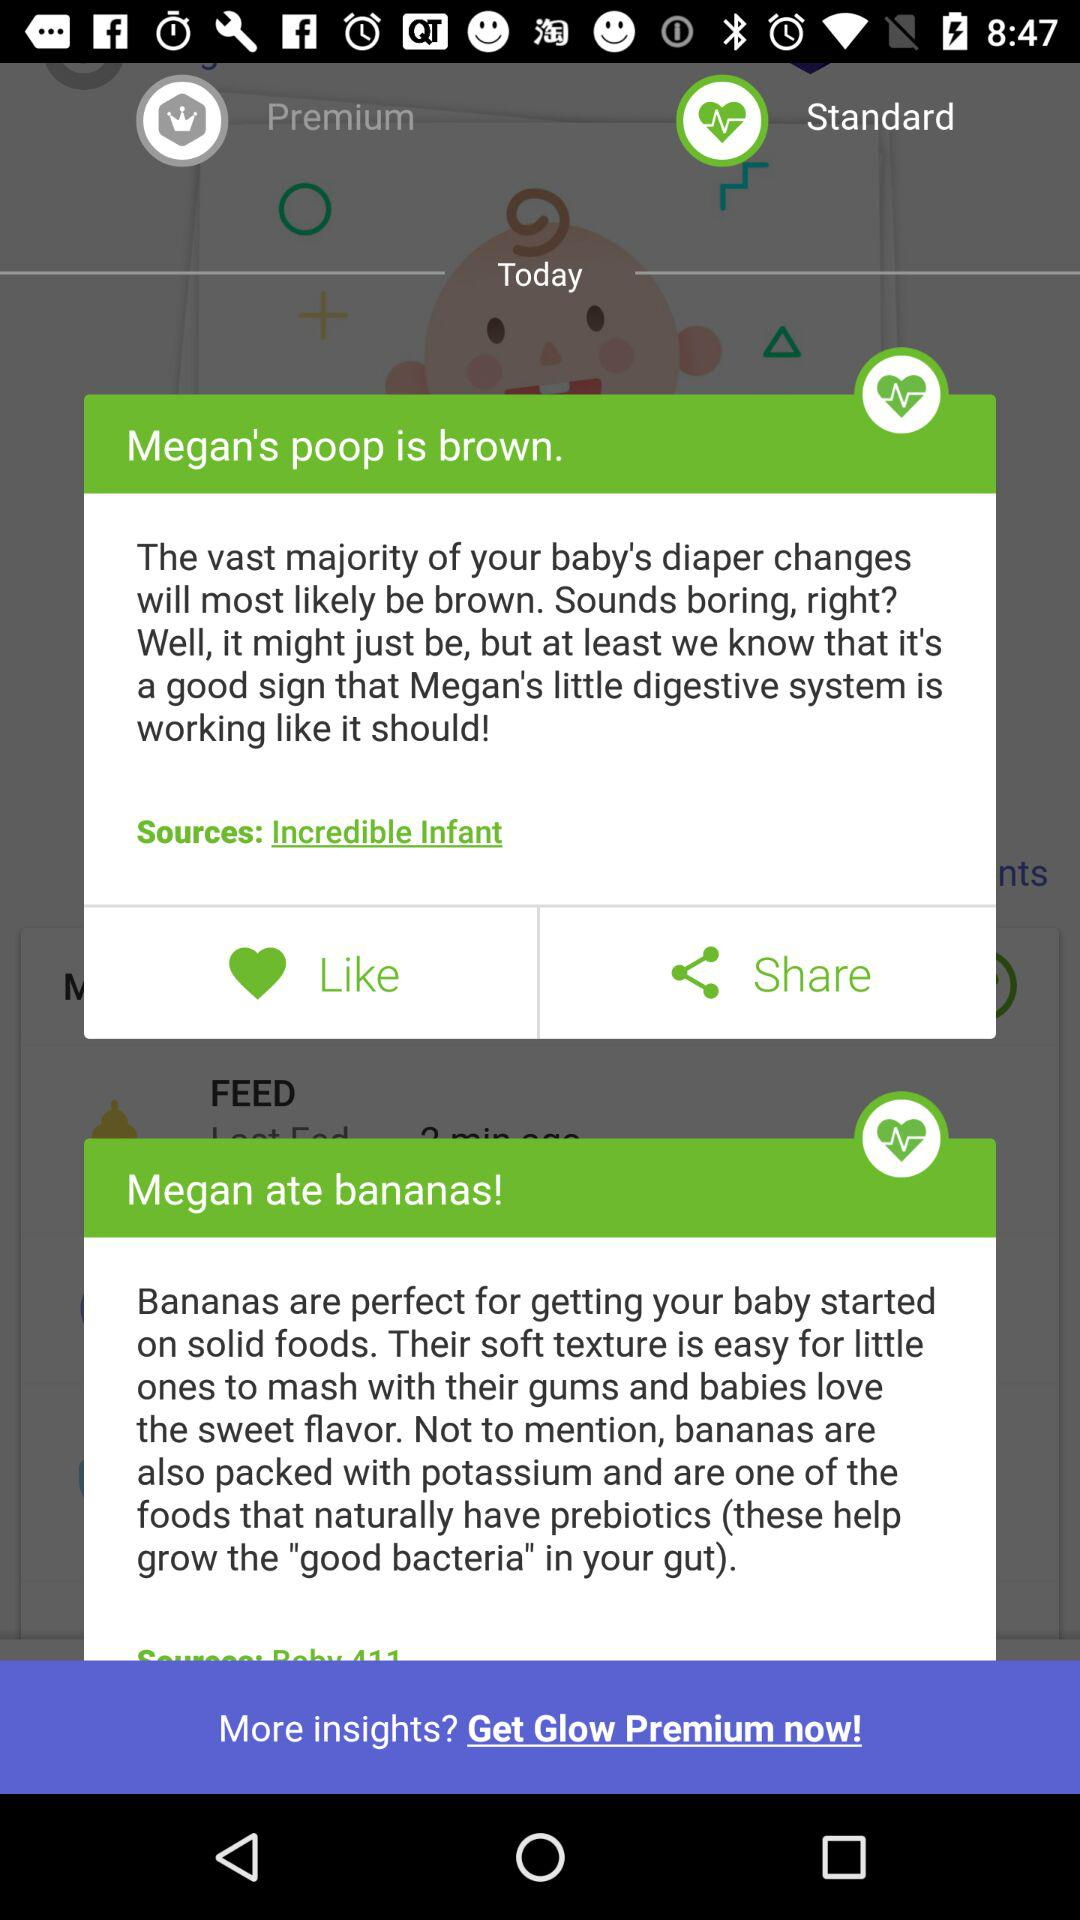Which applications are available for sharing the baby information?
When the provided information is insufficient, respond with <no answer>. <no answer> 